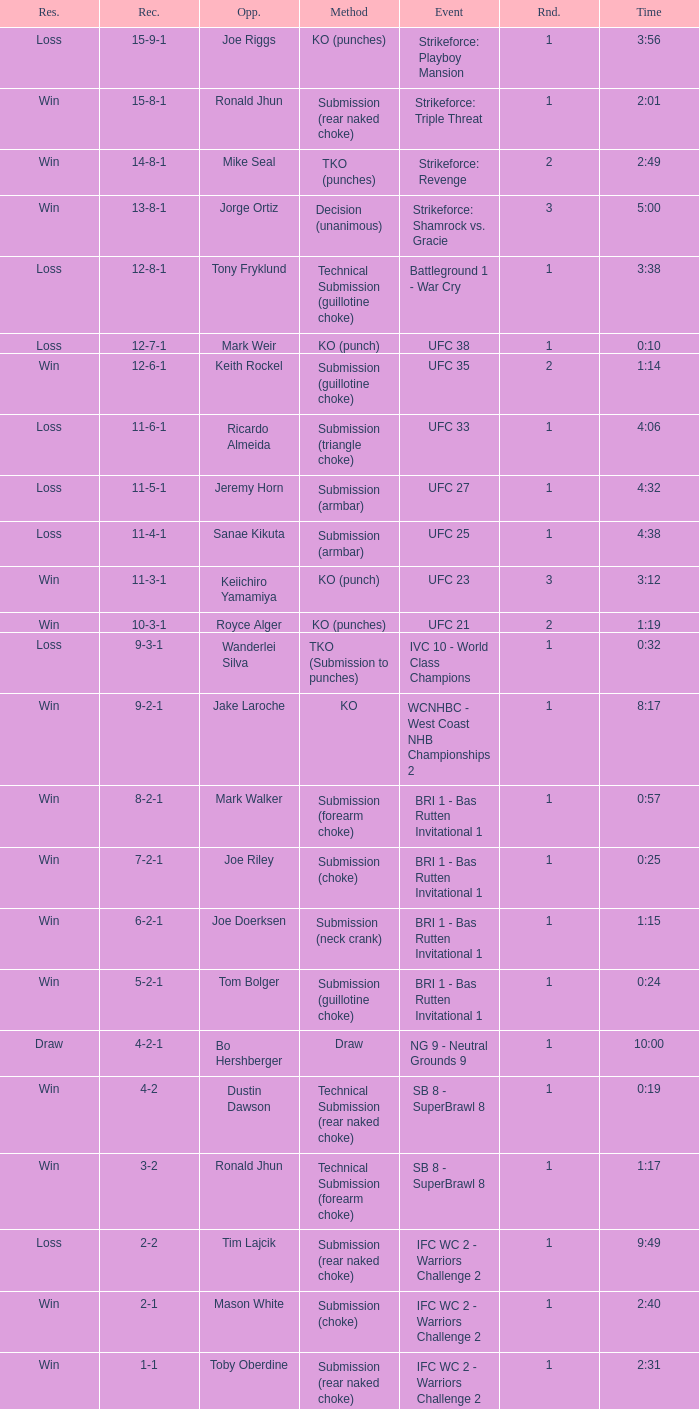What is the record when the fight was against keith rockel? 12-6-1. 